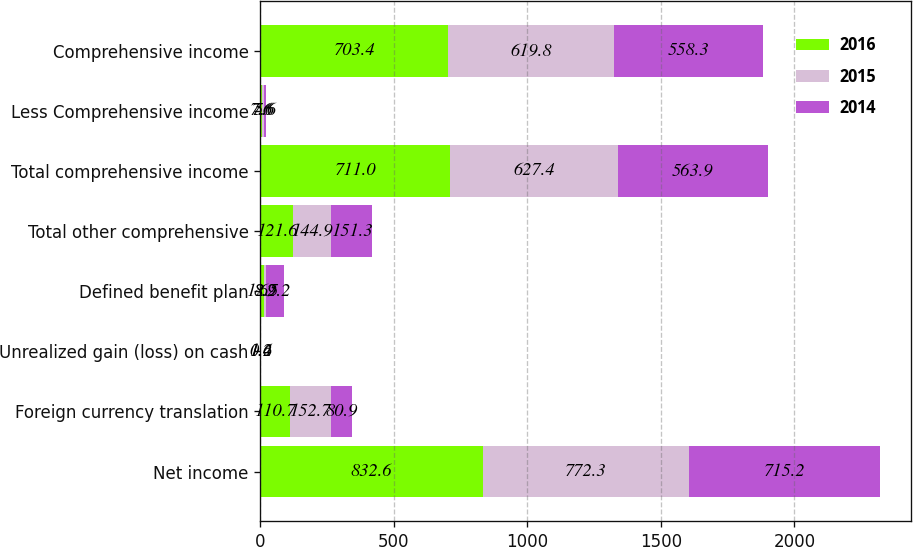Convert chart to OTSL. <chart><loc_0><loc_0><loc_500><loc_500><stacked_bar_chart><ecel><fcel>Net income<fcel>Foreign currency translation<fcel>Unrealized gain (loss) on cash<fcel>Defined benefit plan<fcel>Total other comprehensive<fcel>Total comprehensive income<fcel>Less Comprehensive income<fcel>Comprehensive income<nl><fcel>2016<fcel>832.6<fcel>110.7<fcel>1.6<fcel>12.5<fcel>121.6<fcel>711<fcel>7.6<fcel>703.4<nl><fcel>2015<fcel>772.3<fcel>152.7<fcel>0.4<fcel>8.2<fcel>144.9<fcel>627.4<fcel>7.6<fcel>619.8<nl><fcel>2014<fcel>715.2<fcel>80.9<fcel>1.2<fcel>69.2<fcel>151.3<fcel>563.9<fcel>5.6<fcel>558.3<nl></chart> 